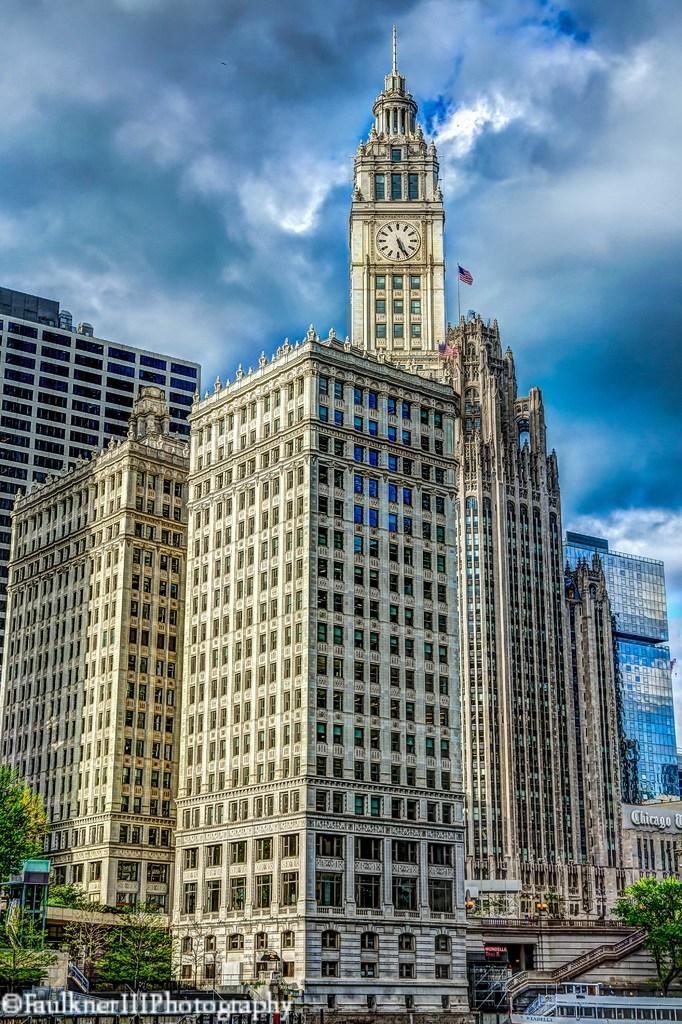What type of structures are visible in the image? There are buildings in the image, including a clock tower. What other natural elements can be seen in the image? There are trees in the image. What is visible in the background of the image? The sky is visible in the background of the image, with clouds present. Is there any text in the image? Yes, there is text in the bottom left corner of the image. What type of lock is securing the lamp in the image? There is no lamp or lock present in the image. 